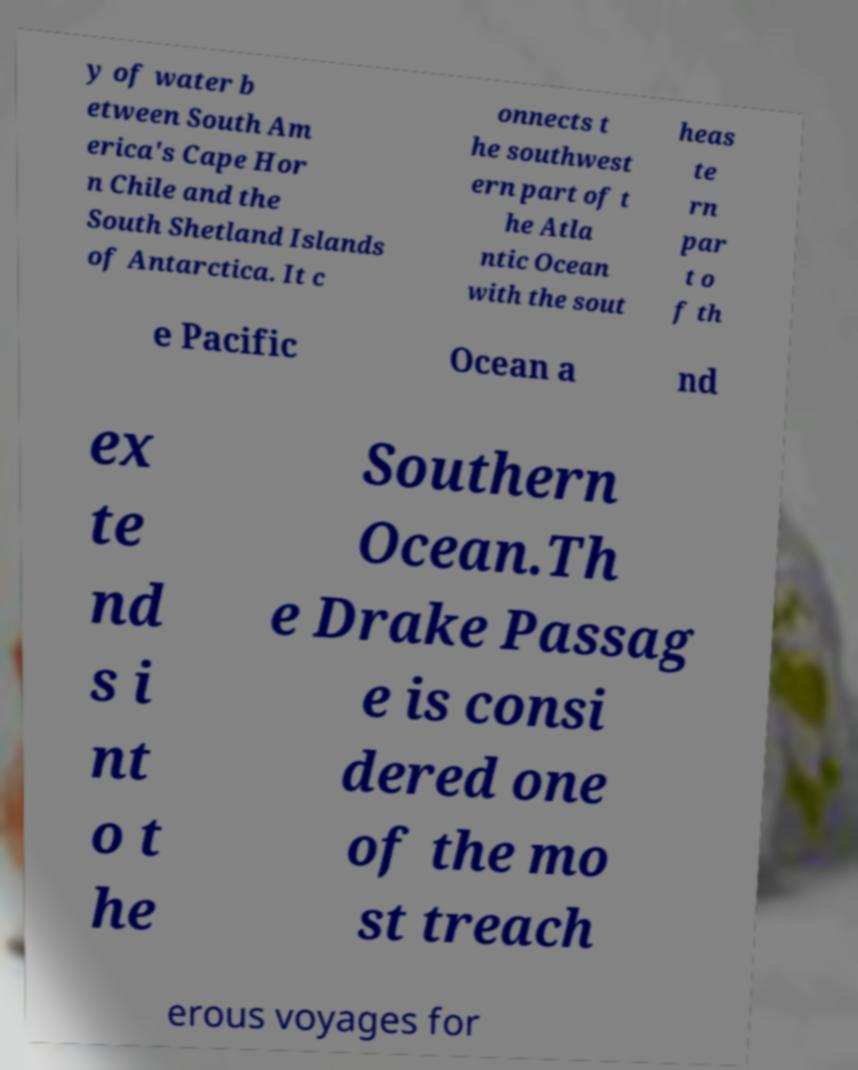Could you extract and type out the text from this image? y of water b etween South Am erica's Cape Hor n Chile and the South Shetland Islands of Antarctica. It c onnects t he southwest ern part of t he Atla ntic Ocean with the sout heas te rn par t o f th e Pacific Ocean a nd ex te nd s i nt o t he Southern Ocean.Th e Drake Passag e is consi dered one of the mo st treach erous voyages for 